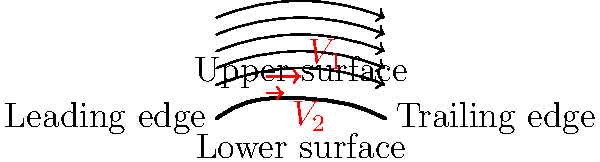As you prepare for your journey to France, imagine you're flying over the beautiful French countryside. The airplane's wing, similar to the airfoil shown, allows for smooth flight. Based on the diagram, which velocity vector ($V_1$ or $V_2$) represents the higher airflow speed, and how does this relate to the pressure difference that creates lift? To understand this concept, let's break it down step-by-step:

1. Airfoil shape: The diagram shows a basic airfoil shape, similar to an airplane wing cross-section.

2. Airflow: The curved lines with arrows represent the airflow around the airfoil.

3. Velocity vectors: Two red arrows labeled $V_1$ and $V_2$ represent air velocity at different points.

4. Bernoulli's principle: This principle states that as the speed of a fluid (in this case, air) increases, its pressure decreases.

5. Airfoil design: The upper surface of the airfoil is more curved than the lower surface.

6. Airflow path: Air traveling over the upper surface must cover a greater distance in the same time as air traveling under the airfoil.

7. Velocity difference: To cover this greater distance, the air over the upper surface must move faster. Therefore, $V_1$ (upper surface) is greater than $V_2$ (lower surface).

8. Pressure difference: According to Bernoulli's principle, the faster-moving air on the upper surface creates a lower pressure area compared to the slower-moving air on the lower surface.

9. Lift generation: This pressure difference between the upper and lower surfaces of the airfoil creates an upward force called lift, which keeps the airplane in the air.
Answer: $V_1$ (upper surface); faster air creates lower pressure, generating lift. 